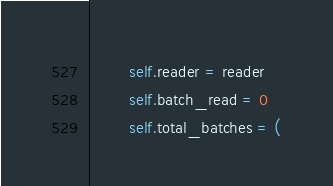Convert code to text. <code><loc_0><loc_0><loc_500><loc_500><_Python_>        self.reader = reader
        self.batch_read = 0
        self.total_batches = (</code> 